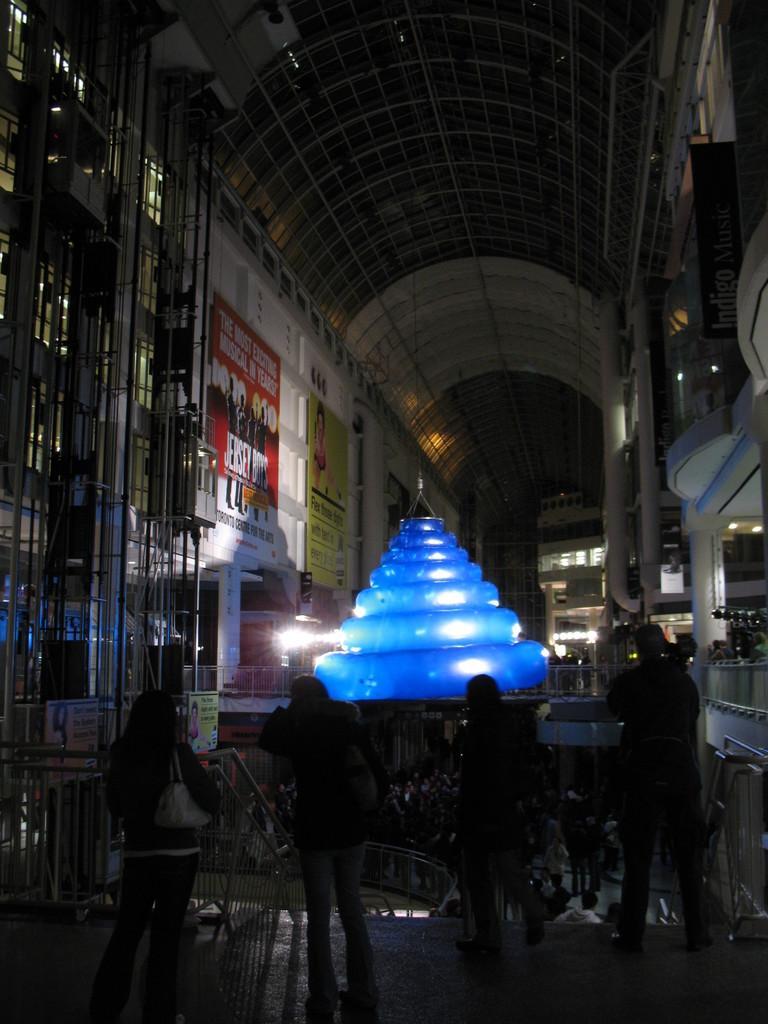Please provide a concise description of this image. In the center of the image we can see a few people are standing and they are holding some objects. And we can see fences and one blue color object, which is tied with the rope. In the background there is a wall, roof, banners, pillars, lights and a few other objects. 